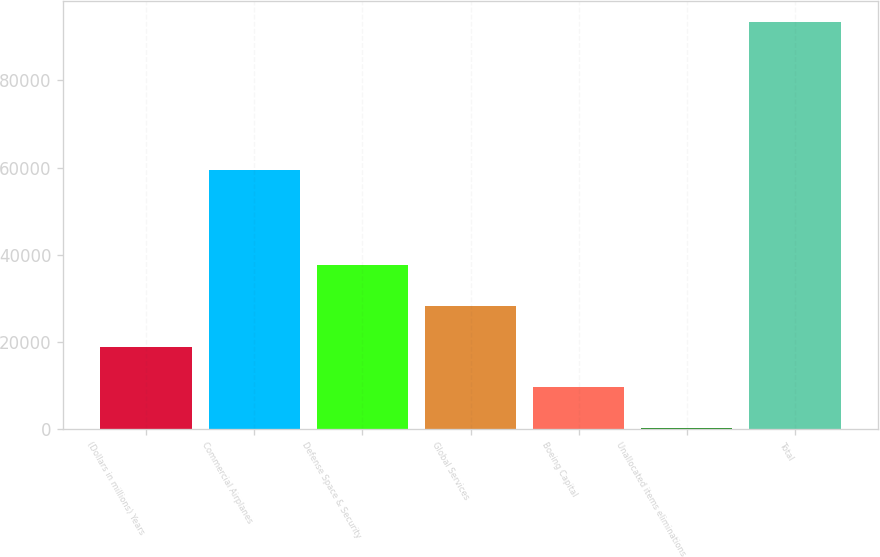<chart> <loc_0><loc_0><loc_500><loc_500><bar_chart><fcel>(Dollars in millions) Years<fcel>Commercial Airplanes<fcel>Defense Space & Security<fcel>Global Services<fcel>Boeing Capital<fcel>Unallocated items eliminations<fcel>Total<nl><fcel>18842.4<fcel>59378<fcel>37505.8<fcel>28174.1<fcel>9510.7<fcel>179<fcel>93496<nl></chart> 